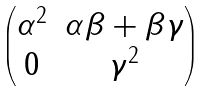<formula> <loc_0><loc_0><loc_500><loc_500>\begin{pmatrix} \alpha ^ { 2 } & \alpha \beta + \beta \gamma \\ 0 & \gamma ^ { 2 } \end{pmatrix}</formula> 